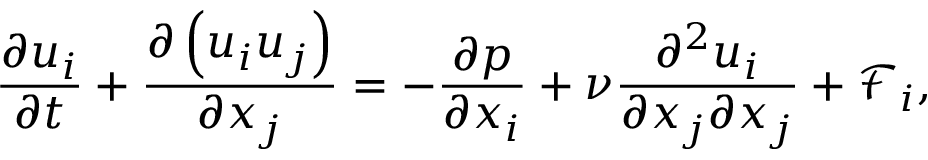Convert formula to latex. <formula><loc_0><loc_0><loc_500><loc_500>\frac { { \partial { u _ { i } } } } { \partial t } + \frac { { \partial \left ( { { u _ { i } } { u _ { j } } } \right ) } } { { \partial { x _ { j } } } } = - \frac { \partial p } { { \partial { x _ { i } } } } + \nu \frac { { { \partial ^ { 2 } } { u _ { i } } } } { { \partial { x _ { j } } \partial { x _ { j } } } } + { { \mathcal { F } } _ { i } } ,</formula> 